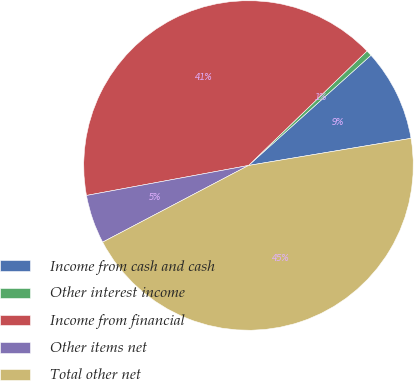Convert chart. <chart><loc_0><loc_0><loc_500><loc_500><pie_chart><fcel>Income from cash and cash<fcel>Other interest income<fcel>Income from financial<fcel>Other items net<fcel>Total other net<nl><fcel>9.03%<fcel>0.56%<fcel>40.69%<fcel>4.79%<fcel>44.93%<nl></chart> 